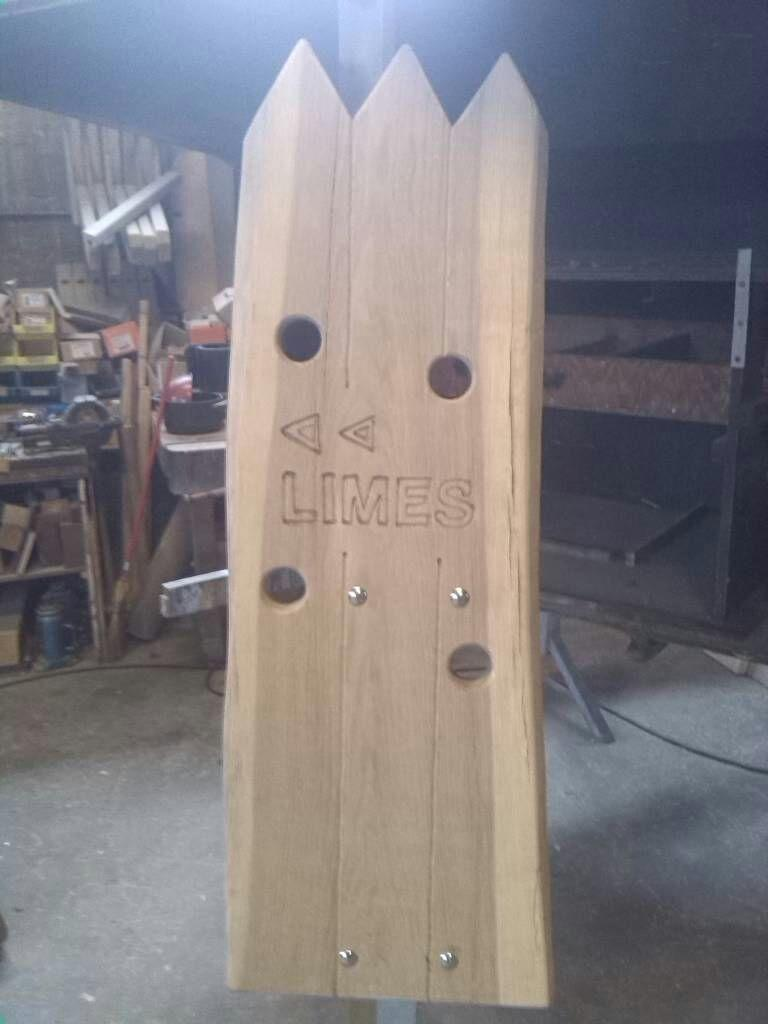What material is the main object in the image made of? The main object in the image is a wooden board. What type of objects can be seen in the image besides the wooden board? There are steel objects and carving visible in the image. What can be seen in the background of the image? The background of the image includes wooden objects and other unspecified things. What is visible at the bottom of the image? There is a floor visible at the bottom of the image. What type of tax is being discussed in the image? There is no discussion of tax in the image; it features a wooden board, steel objects, carving, and a background with wooden objects and other unspecified things. 